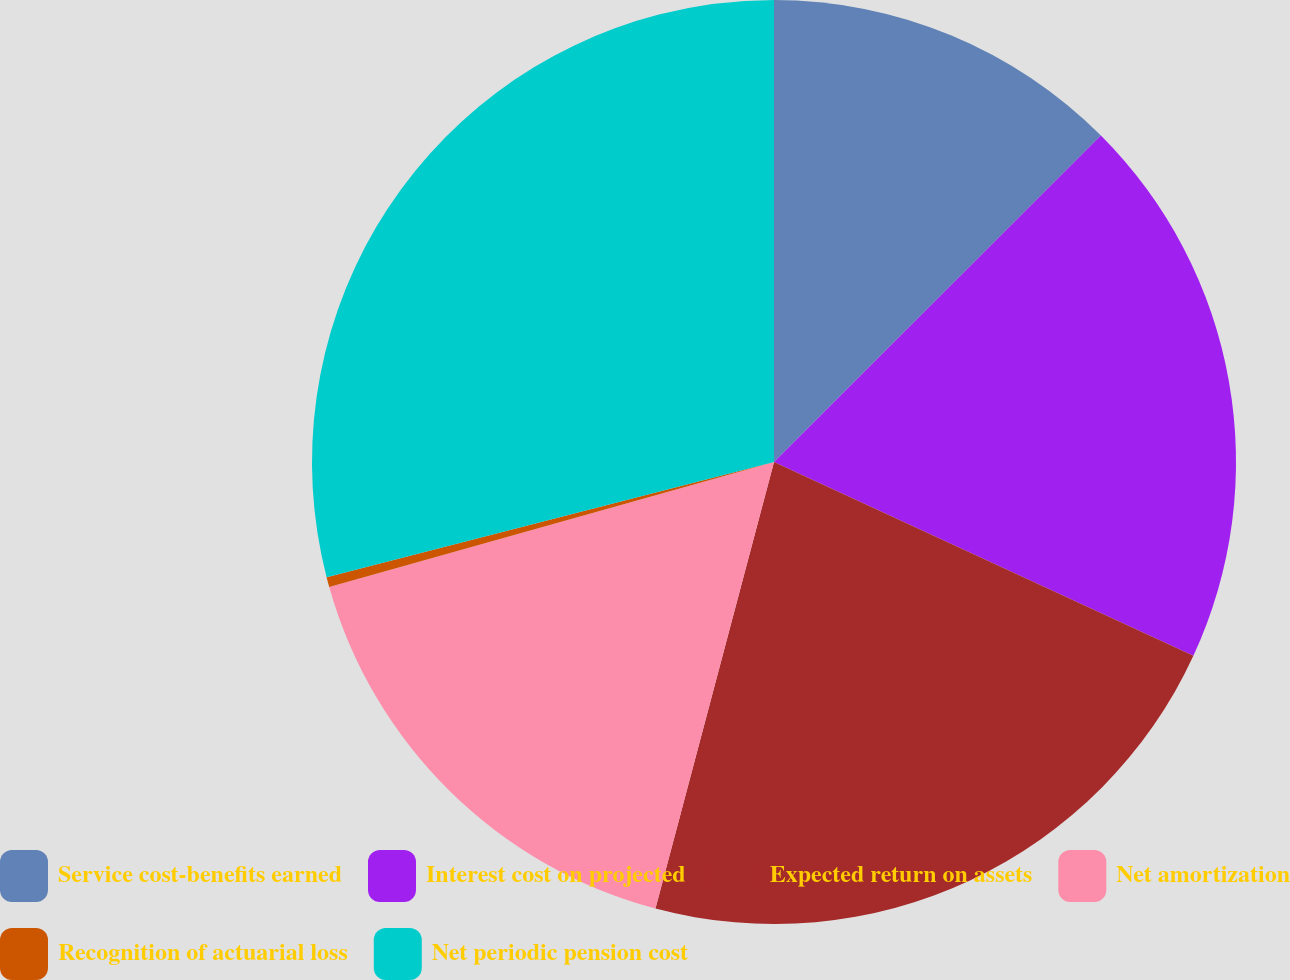<chart> <loc_0><loc_0><loc_500><loc_500><pie_chart><fcel>Service cost-benefits earned<fcel>Interest cost on projected<fcel>Expected return on assets<fcel>Net amortization<fcel>Recognition of actuarial loss<fcel>Net periodic pension cost<nl><fcel>12.51%<fcel>19.38%<fcel>22.24%<fcel>16.51%<fcel>0.35%<fcel>29.01%<nl></chart> 